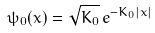Convert formula to latex. <formula><loc_0><loc_0><loc_500><loc_500>\psi _ { 0 } ( x ) = \sqrt { K _ { 0 } } \, e ^ { - K _ { 0 } | x | }</formula> 